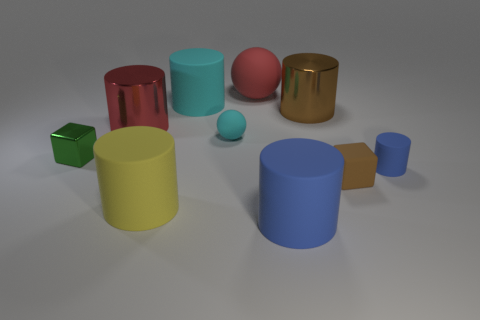There is a red rubber thing; are there any big yellow cylinders on the right side of it? There are no big yellow cylinders to the right side of the red object; the right side contains a blue cylinder and a green cube. 